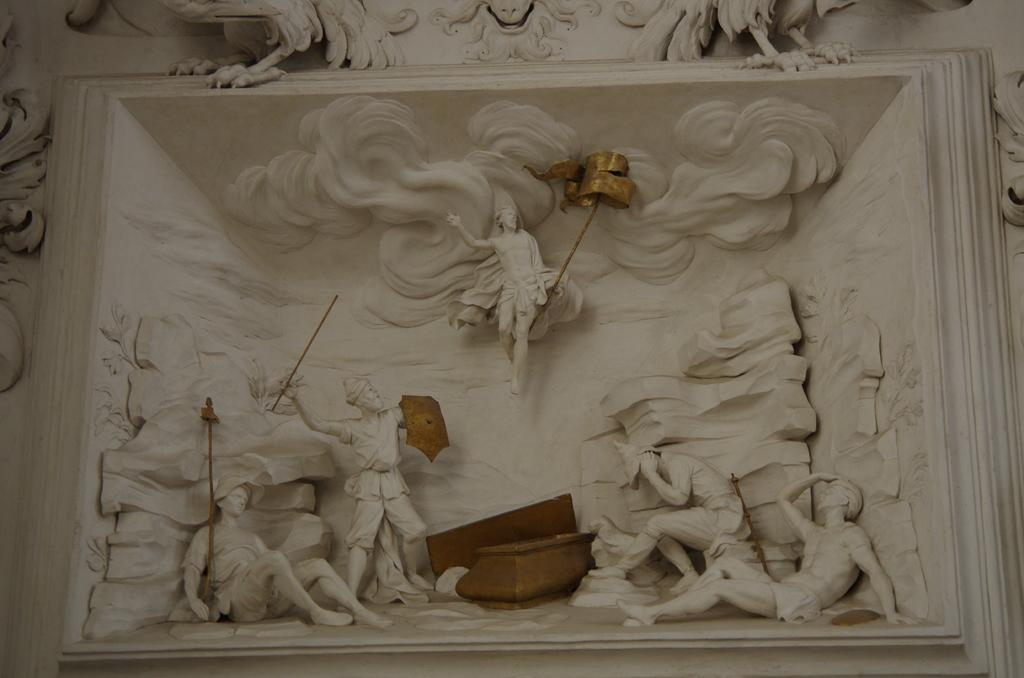What is the nature of the image? The image appears to be handcrafted. What can be seen in the middle of the image? There are statues in the middle of the image. What is the aftermath of the laborer's work in the image? There is no laborer or aftermath present in the image; it only features statues. 